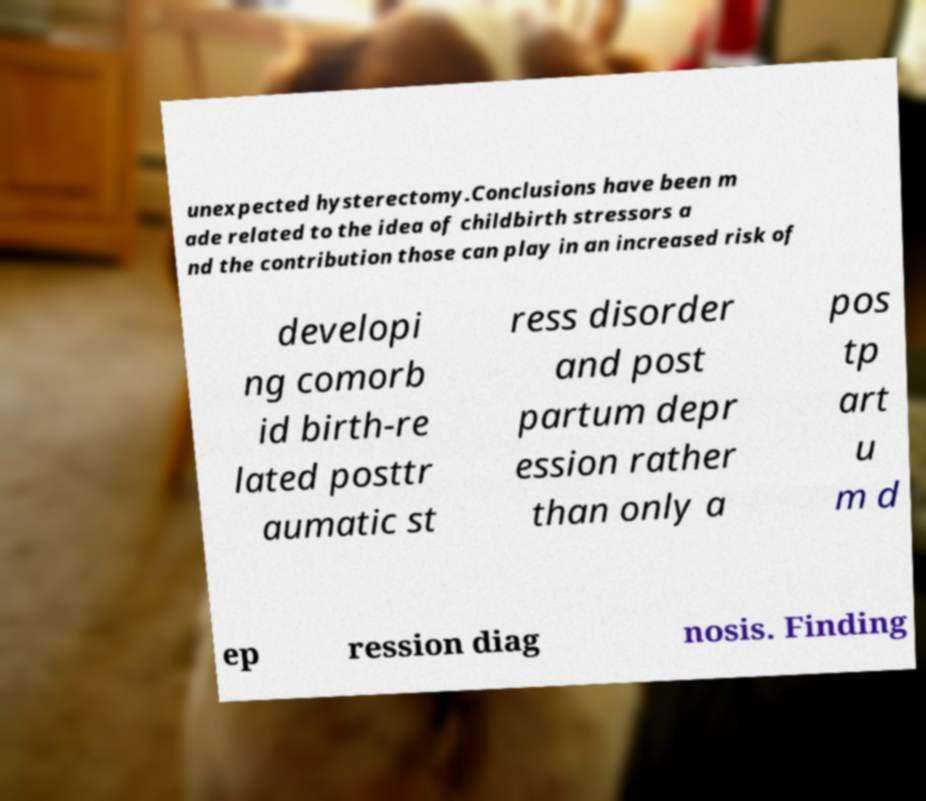For documentation purposes, I need the text within this image transcribed. Could you provide that? unexpected hysterectomy.Conclusions have been m ade related to the idea of childbirth stressors a nd the contribution those can play in an increased risk of developi ng comorb id birth-re lated posttr aumatic st ress disorder and post partum depr ession rather than only a pos tp art u m d ep ression diag nosis. Finding 